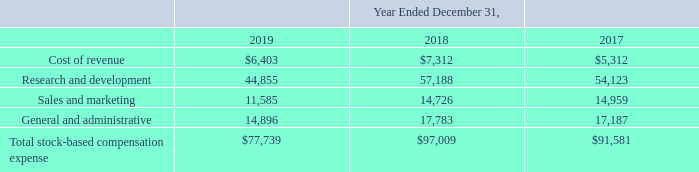The weighted-average grant date fair value of stock options granted during 2017 was $2.00 per share. There were no stock options granted in 2019 or 2018. The total grant date fair value of stock options that vested during 2019, 2018, and 2017 was $2.8 million, $10.1 million and $20.2 million, respectively. As of December 31, 2019, the total unrecognized compensation expense related to unvested stock options was $0.3 million, which the Company expects to recognize over an estimated weighted average period of 0.2 years. As of December 31, 2019, the total unrecognized compensation expense related to unvested RSUs was $94.2 million, which the Company expects to recognize over an estimated weighted average period of 1.9 years. As of December 31, 2019, there was zero unrecognized compensation expense related to unvested warrants.
Stock-based compensation is measured at the grant date based on the fair value of the award and is recognized as expense over the requisite service period, which is generally the vesting period of the respective award. The Company accounts for forfeitures as they occur. The fair value of RSUs without market conditions is the fair value of the Company’s Class A common stock on the grant date. The fair value of RSUs with market conditions is estimated using a Monte Carlo simulation model. In determining the fair value of the stock options, warrants and the equity awards issued under the 2015 ESPP, the Company used the Black-Scholes option-pricing model and assumptions discussed below. Each of these inputs is subjective and generally requires significant judgment.
Fair Value of Common Stock—The fair value of the shares of common stock underlying stock options had historically been established by the Company’s board of directors. Following the completion of the IPO, the Company began using the market closing price for the Company’s Class A common stock as reported on the New York Stock Exchange.
Expected Term—The Company does not have sufficient historical exercise data to provide a reasonable basis upon which to estimate expected term due to the limited period of time stock-based awards have been exercisable. As a result, for stock options, the Company used the simplified method to calculate the expected term, which is equal to the average of the stock-based award’s weighted average vesting period and its contractual term. The expected term of the 2015 ESPP was based on the contractual term.
Volatility—The Company estimates the expected volatility of the common stock underlying its stock options at the grant date. Prior to 2018, the Company estimated the expected volatility of the common stock underlying stock options, warrants and equity awards issued under its 2015 ESPP at the grant date by taking the average historical volatility of the common stock of a group of comparable publicly traded companies over a period equal to the expected life. The Company used this method because it had limited information on the volatility of its Class A common stock because of its short trading history. Beginning in 2018, the Company used a combination of historical volatility from its Class A common stock along with historical volatility from the group of comparable publicly traded companies.
Risk-Free Rate—The risk-free interest rate is estimated average interest rate based on U.S. Treasury zero-coupon notes with terms consistent with the expected term of the awards.
Dividend Yield—The Company has never declared or paid any cash dividends and does not presently plan to pay cash dividends in the foreseeable future. Consequently, it used an expected dividend yield of zero.
The assumptions used in calculating the fair value of the stock-based awards represent management judgment. As a result, if factors change and different assumptions are used, the stock-based compensation expense could be materially different in the future. The fair value of the stock option awards, warrants, awards issued under the 2015 ESPP, and awards granted to employees was estimated at the date of grant using a Black-Scholes option-pricing model. The fair value of the RSUs with market conditions were estimated using a Black-Scholes option-pricing model combined with a Monte Carlo simulation model. The fair value of these awards were estimated using the following Black-Scholes assumptions:
What is the expected dividend yield? Zero. What model is used to estimate the fair value of RSUs with market conditions? Monte carlo simulation model. What is the weighted-average grant date fair value of stock options granted in 2017? $2.00. What is the average cost of revenue from 2017-2019?
Answer scale should be: thousand. (6,403+7,312+5,312)/3
Answer: 6342.33. What is the difference in research and development costs between 2018 and 2019?
Answer scale should be: thousand. 57,188-44,855
Answer: 12333. In 2019, what is the percentage constitution of sales and marketing costs among the total stock-based compensation expense?
Answer scale should be: percent. 11,585/77,739
Answer: 14.9. 